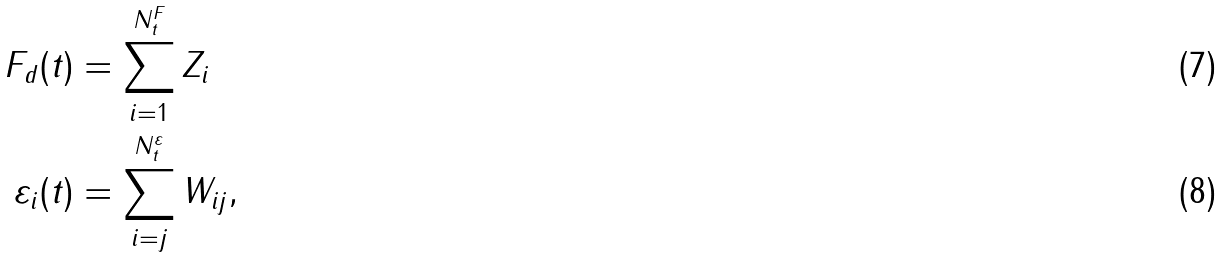<formula> <loc_0><loc_0><loc_500><loc_500>F _ { d } ( t ) & = \sum _ { i = 1 } ^ { N ^ { F } _ { t } } Z _ { i } \\ \varepsilon _ { i } ( t ) & = \sum _ { i = j } ^ { N ^ { \varepsilon } _ { t } } { W } _ { i j } ,</formula> 